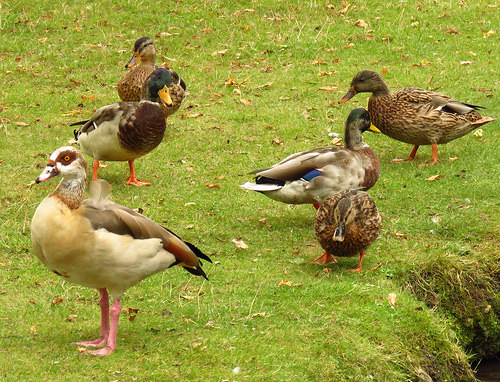<image>
Is there a duck on the duck? No. The duck is not positioned on the duck. They may be near each other, but the duck is not supported by or resting on top of the duck. Where is the bird in relation to the land? Is it above the land? No. The bird is not positioned above the land. The vertical arrangement shows a different relationship. 